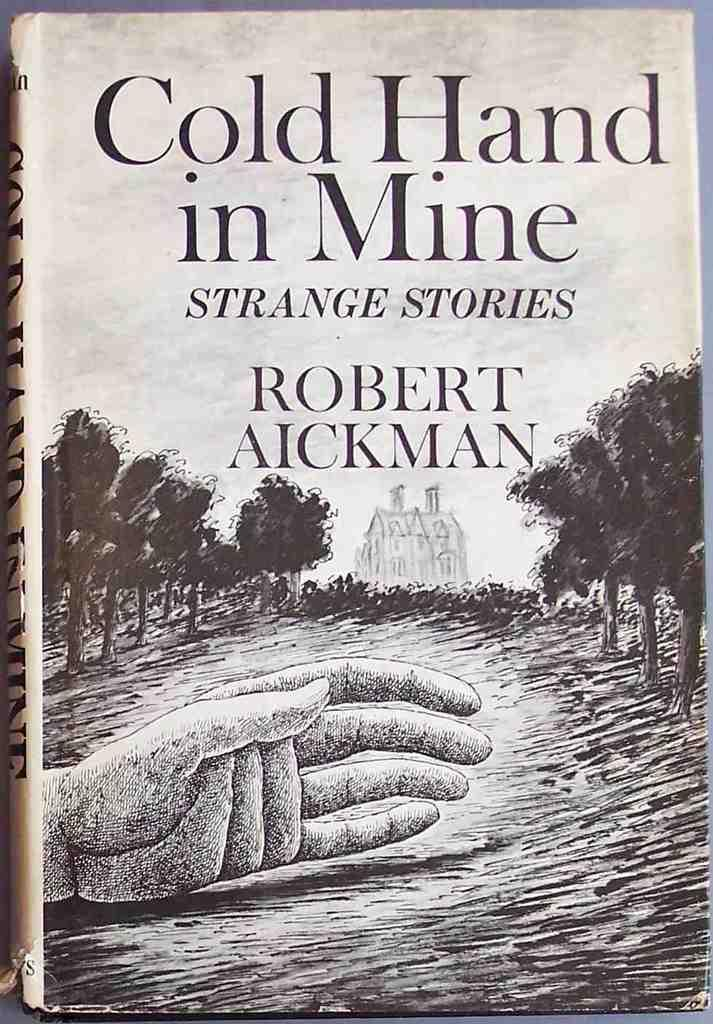<image>
Render a clear and concise summary of the photo. A book called Cold Hand in Mine has an ink illustrated cover. 